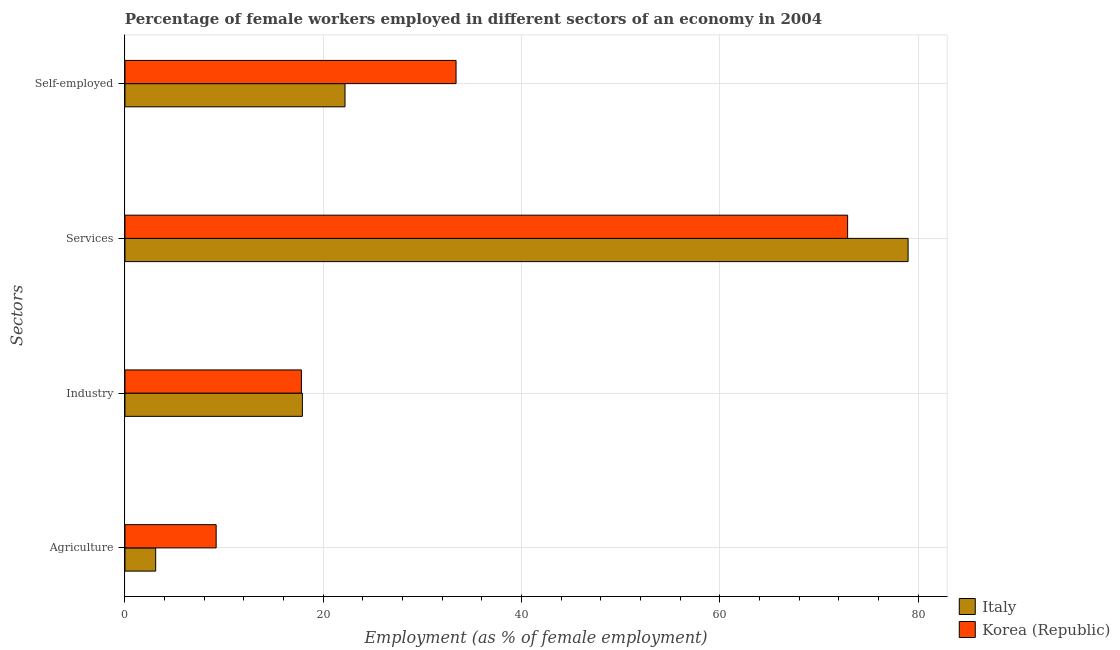Are the number of bars per tick equal to the number of legend labels?
Offer a terse response. Yes. What is the label of the 3rd group of bars from the top?
Your response must be concise. Industry. What is the percentage of female workers in agriculture in Italy?
Provide a succinct answer. 3.1. Across all countries, what is the maximum percentage of female workers in services?
Your answer should be very brief. 79. Across all countries, what is the minimum percentage of female workers in services?
Your response must be concise. 72.9. In which country was the percentage of female workers in industry maximum?
Make the answer very short. Italy. In which country was the percentage of female workers in agriculture minimum?
Ensure brevity in your answer.  Italy. What is the total percentage of female workers in industry in the graph?
Provide a short and direct response. 35.7. What is the difference between the percentage of self employed female workers in Italy and that in Korea (Republic)?
Provide a short and direct response. -11.2. What is the difference between the percentage of female workers in agriculture in Korea (Republic) and the percentage of female workers in industry in Italy?
Make the answer very short. -8.7. What is the average percentage of self employed female workers per country?
Provide a short and direct response. 27.8. What is the difference between the percentage of female workers in industry and percentage of self employed female workers in Korea (Republic)?
Your answer should be compact. -15.6. What is the ratio of the percentage of female workers in industry in Korea (Republic) to that in Italy?
Your answer should be compact. 0.99. Is the difference between the percentage of female workers in agriculture in Korea (Republic) and Italy greater than the difference between the percentage of female workers in services in Korea (Republic) and Italy?
Offer a very short reply. Yes. What is the difference between the highest and the second highest percentage of female workers in agriculture?
Give a very brief answer. 6.1. What is the difference between the highest and the lowest percentage of female workers in agriculture?
Your answer should be compact. 6.1. In how many countries, is the percentage of female workers in services greater than the average percentage of female workers in services taken over all countries?
Make the answer very short. 1. Is it the case that in every country, the sum of the percentage of female workers in industry and percentage of female workers in services is greater than the sum of percentage of self employed female workers and percentage of female workers in agriculture?
Offer a very short reply. No. What does the 1st bar from the top in Self-employed represents?
Your answer should be very brief. Korea (Republic). How many bars are there?
Your answer should be compact. 8. Are all the bars in the graph horizontal?
Give a very brief answer. Yes. How many countries are there in the graph?
Your response must be concise. 2. Are the values on the major ticks of X-axis written in scientific E-notation?
Ensure brevity in your answer.  No. Does the graph contain grids?
Provide a succinct answer. Yes. Where does the legend appear in the graph?
Give a very brief answer. Bottom right. How many legend labels are there?
Your response must be concise. 2. What is the title of the graph?
Make the answer very short. Percentage of female workers employed in different sectors of an economy in 2004. Does "South Asia" appear as one of the legend labels in the graph?
Give a very brief answer. No. What is the label or title of the X-axis?
Provide a short and direct response. Employment (as % of female employment). What is the label or title of the Y-axis?
Your response must be concise. Sectors. What is the Employment (as % of female employment) in Italy in Agriculture?
Provide a short and direct response. 3.1. What is the Employment (as % of female employment) of Korea (Republic) in Agriculture?
Offer a very short reply. 9.2. What is the Employment (as % of female employment) of Italy in Industry?
Offer a terse response. 17.9. What is the Employment (as % of female employment) of Korea (Republic) in Industry?
Make the answer very short. 17.8. What is the Employment (as % of female employment) of Italy in Services?
Provide a short and direct response. 79. What is the Employment (as % of female employment) of Korea (Republic) in Services?
Keep it short and to the point. 72.9. What is the Employment (as % of female employment) of Italy in Self-employed?
Ensure brevity in your answer.  22.2. What is the Employment (as % of female employment) in Korea (Republic) in Self-employed?
Make the answer very short. 33.4. Across all Sectors, what is the maximum Employment (as % of female employment) in Italy?
Offer a terse response. 79. Across all Sectors, what is the maximum Employment (as % of female employment) of Korea (Republic)?
Offer a terse response. 72.9. Across all Sectors, what is the minimum Employment (as % of female employment) in Italy?
Your answer should be compact. 3.1. Across all Sectors, what is the minimum Employment (as % of female employment) in Korea (Republic)?
Give a very brief answer. 9.2. What is the total Employment (as % of female employment) in Italy in the graph?
Your response must be concise. 122.2. What is the total Employment (as % of female employment) in Korea (Republic) in the graph?
Provide a short and direct response. 133.3. What is the difference between the Employment (as % of female employment) of Italy in Agriculture and that in Industry?
Give a very brief answer. -14.8. What is the difference between the Employment (as % of female employment) of Korea (Republic) in Agriculture and that in Industry?
Make the answer very short. -8.6. What is the difference between the Employment (as % of female employment) in Italy in Agriculture and that in Services?
Your answer should be very brief. -75.9. What is the difference between the Employment (as % of female employment) of Korea (Republic) in Agriculture and that in Services?
Give a very brief answer. -63.7. What is the difference between the Employment (as % of female employment) in Italy in Agriculture and that in Self-employed?
Your response must be concise. -19.1. What is the difference between the Employment (as % of female employment) of Korea (Republic) in Agriculture and that in Self-employed?
Your answer should be compact. -24.2. What is the difference between the Employment (as % of female employment) of Italy in Industry and that in Services?
Keep it short and to the point. -61.1. What is the difference between the Employment (as % of female employment) of Korea (Republic) in Industry and that in Services?
Provide a succinct answer. -55.1. What is the difference between the Employment (as % of female employment) in Italy in Industry and that in Self-employed?
Your answer should be very brief. -4.3. What is the difference between the Employment (as % of female employment) of Korea (Republic) in Industry and that in Self-employed?
Ensure brevity in your answer.  -15.6. What is the difference between the Employment (as % of female employment) of Italy in Services and that in Self-employed?
Offer a terse response. 56.8. What is the difference between the Employment (as % of female employment) in Korea (Republic) in Services and that in Self-employed?
Ensure brevity in your answer.  39.5. What is the difference between the Employment (as % of female employment) of Italy in Agriculture and the Employment (as % of female employment) of Korea (Republic) in Industry?
Offer a terse response. -14.7. What is the difference between the Employment (as % of female employment) in Italy in Agriculture and the Employment (as % of female employment) in Korea (Republic) in Services?
Your answer should be compact. -69.8. What is the difference between the Employment (as % of female employment) in Italy in Agriculture and the Employment (as % of female employment) in Korea (Republic) in Self-employed?
Provide a succinct answer. -30.3. What is the difference between the Employment (as % of female employment) in Italy in Industry and the Employment (as % of female employment) in Korea (Republic) in Services?
Make the answer very short. -55. What is the difference between the Employment (as % of female employment) of Italy in Industry and the Employment (as % of female employment) of Korea (Republic) in Self-employed?
Ensure brevity in your answer.  -15.5. What is the difference between the Employment (as % of female employment) of Italy in Services and the Employment (as % of female employment) of Korea (Republic) in Self-employed?
Your response must be concise. 45.6. What is the average Employment (as % of female employment) in Italy per Sectors?
Your response must be concise. 30.55. What is the average Employment (as % of female employment) in Korea (Republic) per Sectors?
Provide a succinct answer. 33.33. What is the difference between the Employment (as % of female employment) in Italy and Employment (as % of female employment) in Korea (Republic) in Industry?
Offer a terse response. 0.1. What is the difference between the Employment (as % of female employment) of Italy and Employment (as % of female employment) of Korea (Republic) in Self-employed?
Offer a very short reply. -11.2. What is the ratio of the Employment (as % of female employment) in Italy in Agriculture to that in Industry?
Make the answer very short. 0.17. What is the ratio of the Employment (as % of female employment) of Korea (Republic) in Agriculture to that in Industry?
Provide a short and direct response. 0.52. What is the ratio of the Employment (as % of female employment) in Italy in Agriculture to that in Services?
Give a very brief answer. 0.04. What is the ratio of the Employment (as % of female employment) in Korea (Republic) in Agriculture to that in Services?
Offer a very short reply. 0.13. What is the ratio of the Employment (as % of female employment) in Italy in Agriculture to that in Self-employed?
Provide a succinct answer. 0.14. What is the ratio of the Employment (as % of female employment) in Korea (Republic) in Agriculture to that in Self-employed?
Your response must be concise. 0.28. What is the ratio of the Employment (as % of female employment) of Italy in Industry to that in Services?
Offer a very short reply. 0.23. What is the ratio of the Employment (as % of female employment) in Korea (Republic) in Industry to that in Services?
Offer a very short reply. 0.24. What is the ratio of the Employment (as % of female employment) in Italy in Industry to that in Self-employed?
Give a very brief answer. 0.81. What is the ratio of the Employment (as % of female employment) of Korea (Republic) in Industry to that in Self-employed?
Offer a very short reply. 0.53. What is the ratio of the Employment (as % of female employment) in Italy in Services to that in Self-employed?
Your answer should be very brief. 3.56. What is the ratio of the Employment (as % of female employment) in Korea (Republic) in Services to that in Self-employed?
Make the answer very short. 2.18. What is the difference between the highest and the second highest Employment (as % of female employment) of Italy?
Give a very brief answer. 56.8. What is the difference between the highest and the second highest Employment (as % of female employment) of Korea (Republic)?
Offer a terse response. 39.5. What is the difference between the highest and the lowest Employment (as % of female employment) of Italy?
Give a very brief answer. 75.9. What is the difference between the highest and the lowest Employment (as % of female employment) of Korea (Republic)?
Your answer should be very brief. 63.7. 